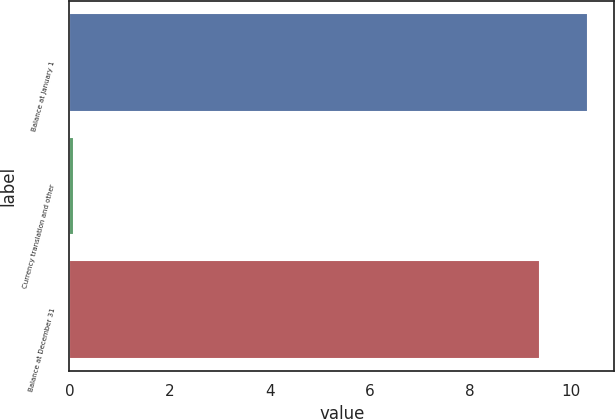Convert chart to OTSL. <chart><loc_0><loc_0><loc_500><loc_500><bar_chart><fcel>Balance at January 1<fcel>Currency translation and other<fcel>Balance at December 31<nl><fcel>10.35<fcel>0.1<fcel>9.4<nl></chart> 